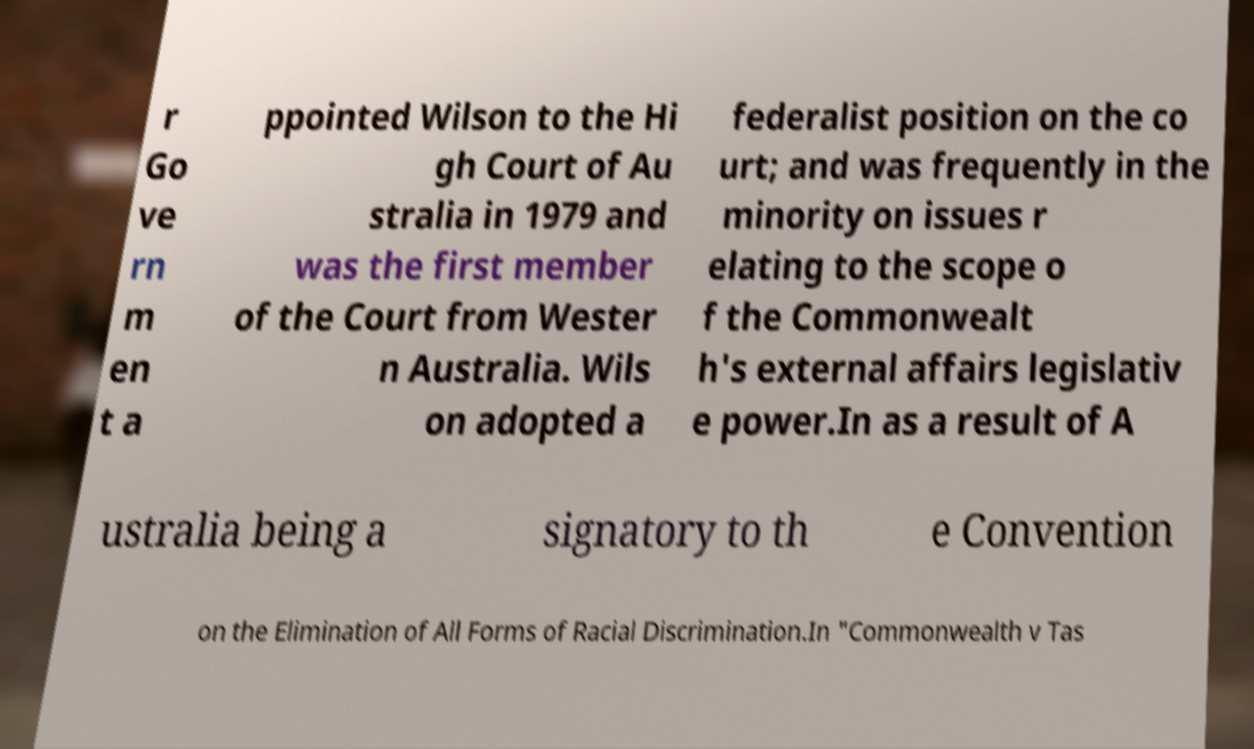Could you assist in decoding the text presented in this image and type it out clearly? r Go ve rn m en t a ppointed Wilson to the Hi gh Court of Au stralia in 1979 and was the first member of the Court from Wester n Australia. Wils on adopted a federalist position on the co urt; and was frequently in the minority on issues r elating to the scope o f the Commonwealt h's external affairs legislativ e power.In as a result of A ustralia being a signatory to th e Convention on the Elimination of All Forms of Racial Discrimination.In "Commonwealth v Tas 